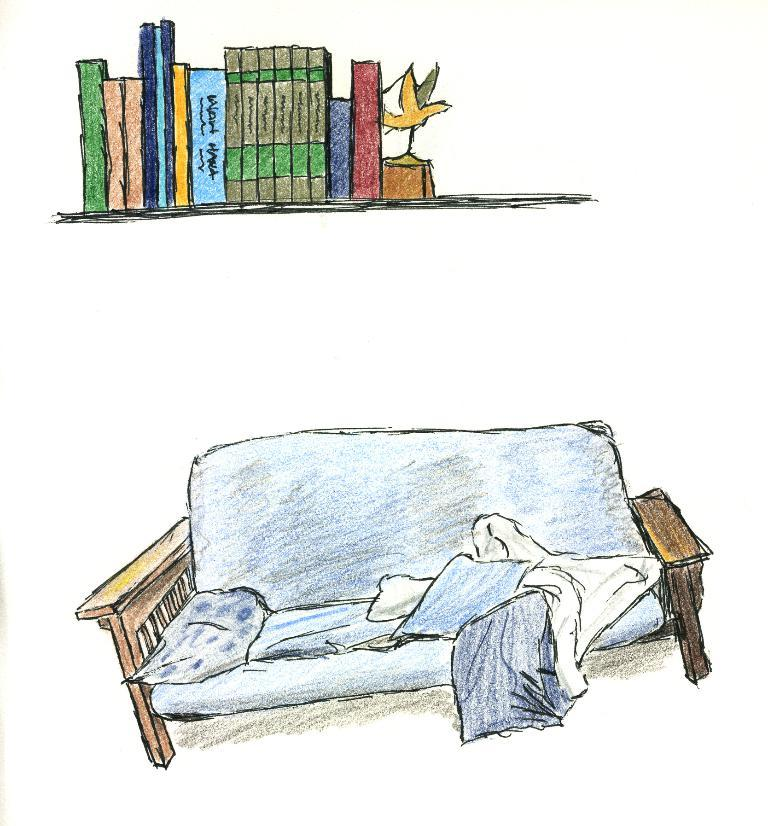What type of artwork is depicted in the image? The image is a painted picture. What piece of furniture can be seen at the bottom of the picture? There is a couch in the bottom of the picture. What object is located at the top of the picture? There is a bookshelf in the top of the picture. What brand of toothpaste is advertised on the couch in the image? There is no toothpaste or advertisement present in the image; it is a painted picture featuring a couch and a bookshelf. 